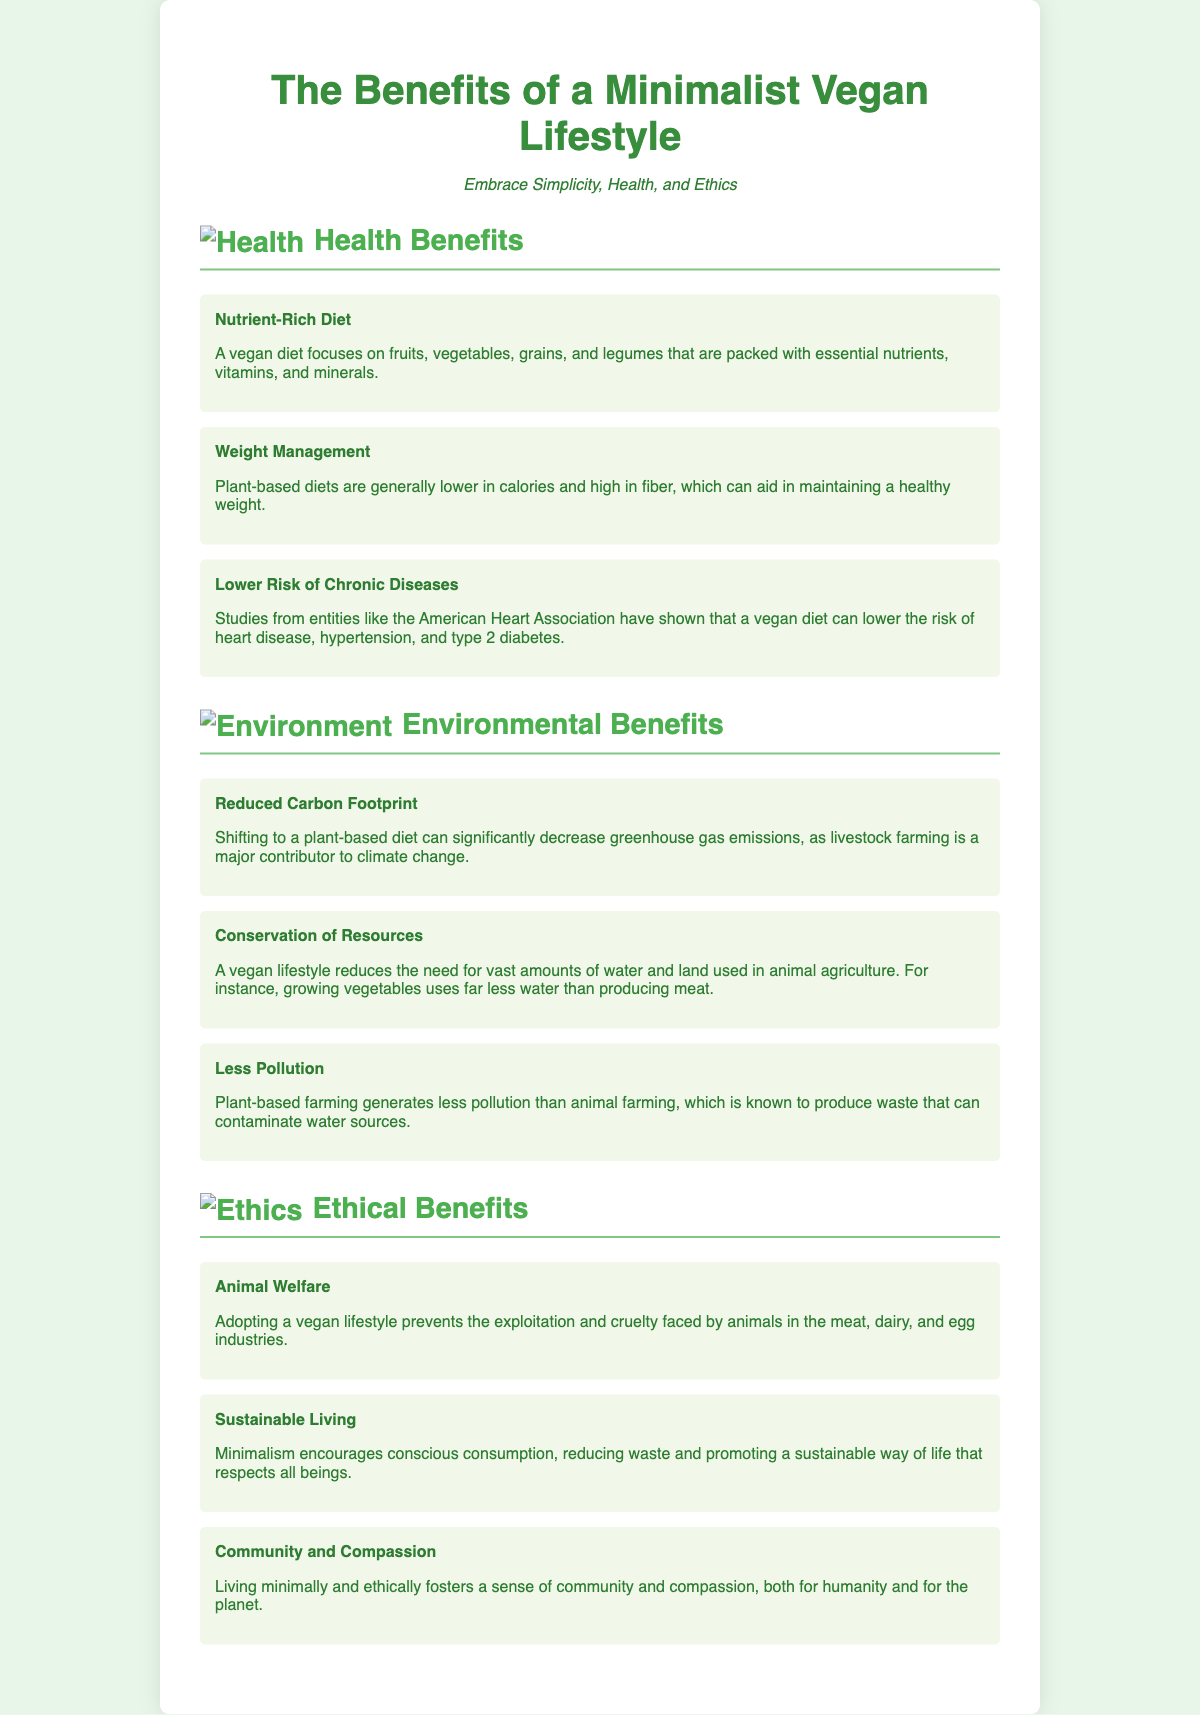What are the main health benefits listed? The document provides three specific health benefits of a minimalist vegan lifestyle: Nutrient-Rich Diet, Weight Management, and Lower Risk of Chronic Diseases.
Answer: Nutrient-Rich Diet, Weight Management, Lower Risk of Chronic Diseases What decreases with a plant-based diet? The poster states that shifting to a plant-based diet can significantly decrease greenhouse gas emissions, which contributes to climate change.
Answer: Greenhouse gas emissions What does a vegan lifestyle help prevent? The document mentions that adopting a vegan lifestyle prevents the exploitation and cruelty faced by animals in the meat, dairy, and egg industries.
Answer: Exploitation and cruelty How many environmental benefits are highlighted? The document lists three environmental benefits of a minimalist vegan lifestyle: Reduced Carbon Footprint, Conservation of Resources, and Less Pollution.
Answer: Three What does minimalism promote according to the ethical benefits? The document explains that minimalism encourages conscious consumption, which reduces waste and promotes a sustainable way of life that respects all beings.
Answer: Conscious consumption What color is the background of the poster? The style section specifies that the background color of the poster is a light green shade (#E8F5E9).
Answer: Light green What is the title of the poster? The title of the poster is clearly stated at the top as "The Benefits of a Minimalist Vegan Lifestyle."
Answer: The Benefits of a Minimalist Vegan Lifestyle What are the three sections of benefits discussed? The poster is divided into three main sections: Health Benefits, Environmental Benefits, and Ethical Benefits.
Answer: Health Benefits, Environmental Benefits, Ethical Benefits 